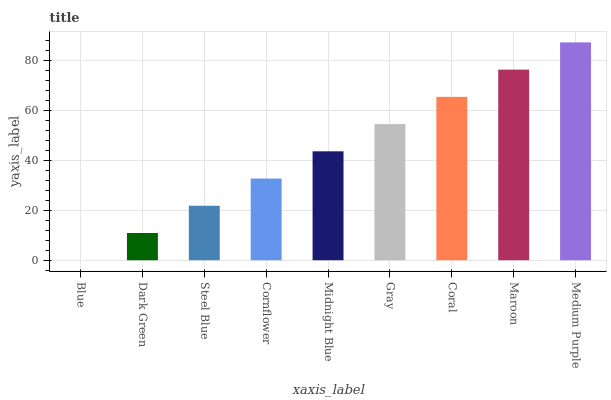Is Blue the minimum?
Answer yes or no. Yes. Is Medium Purple the maximum?
Answer yes or no. Yes. Is Dark Green the minimum?
Answer yes or no. No. Is Dark Green the maximum?
Answer yes or no. No. Is Dark Green greater than Blue?
Answer yes or no. Yes. Is Blue less than Dark Green?
Answer yes or no. Yes. Is Blue greater than Dark Green?
Answer yes or no. No. Is Dark Green less than Blue?
Answer yes or no. No. Is Midnight Blue the high median?
Answer yes or no. Yes. Is Midnight Blue the low median?
Answer yes or no. Yes. Is Medium Purple the high median?
Answer yes or no. No. Is Steel Blue the low median?
Answer yes or no. No. 